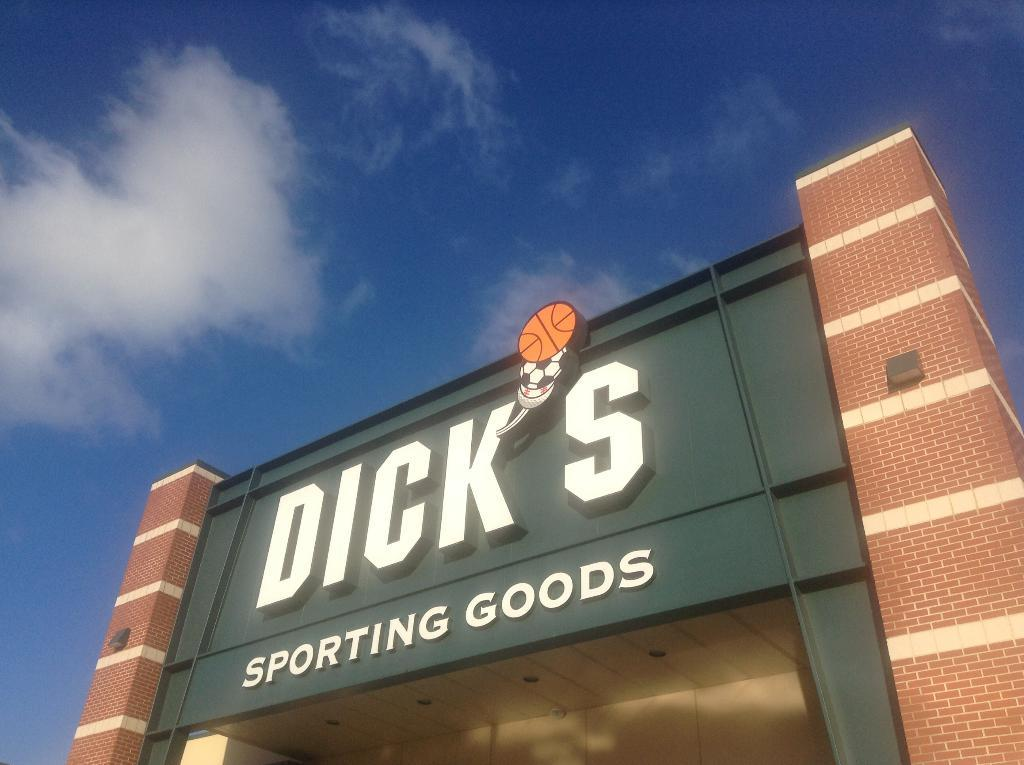What is written on in the image? There is text on a green color board in the image. What type of structure can be seen in the image? There is a building in the image. What is the color of the building? The building is in brown color. What can be seen in the background of the image? There is a sky visible in the background of the image. What is the weather like in the image? The presence of clouds in the sky suggests that it might be partly cloudy. Can you tell me how many cats are sitting on the building in the image? There are no cats present in the image; it features a building with a green color board and text. What type of payment is being made in the image? There is no payment being made in the image; it only shows a building, a green color board with text, and a sky with clouds. 